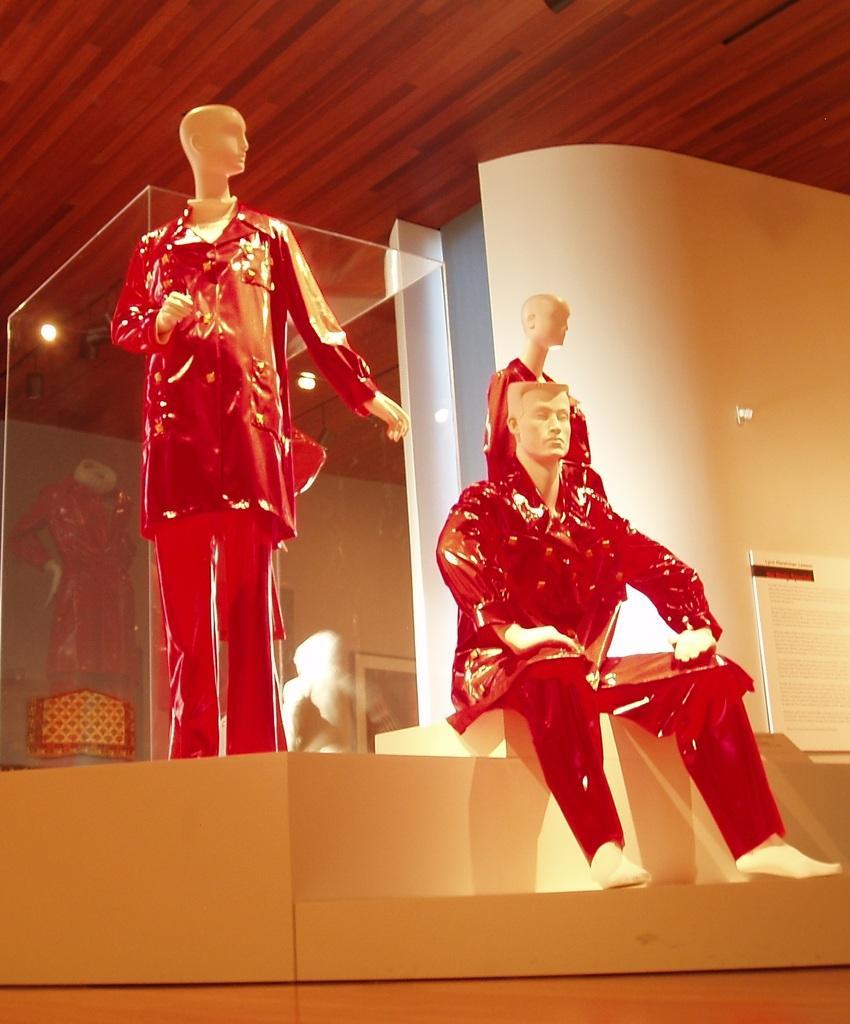Can you describe this image briefly? In this image we can see the mannequins on the surface. We can also see a board, photo frame on a wall, a glass container and a roof with some ceiling lights. 